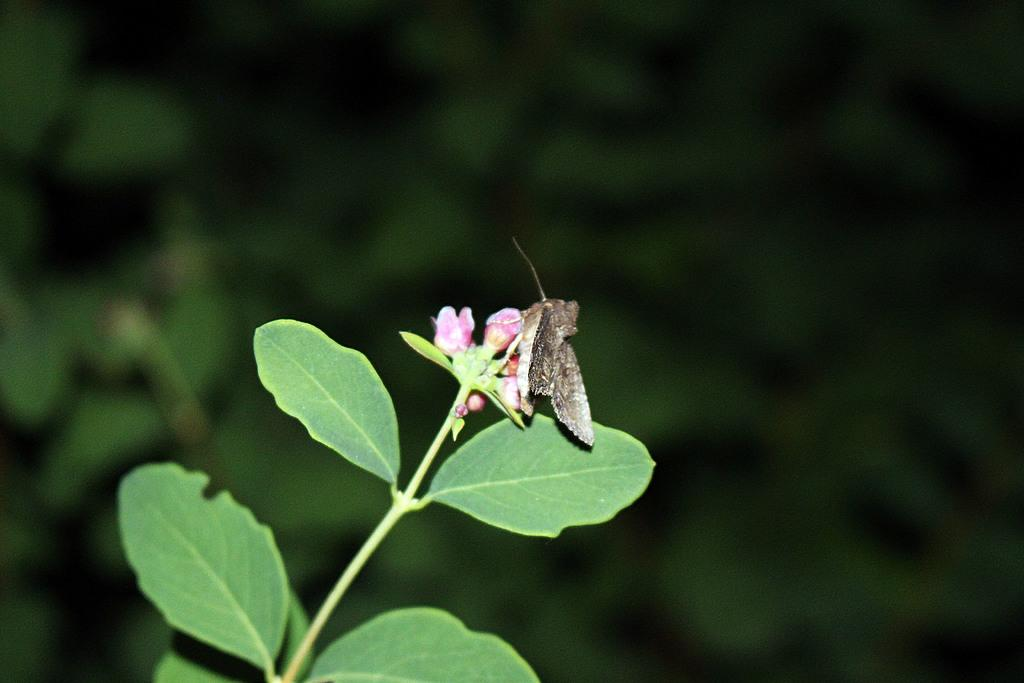What is the main subject of the image? There is a moth in the center of the image. Where is the moth located in the image? The moth is on a bud. What else can be seen in the image besides the moth? There is a plant in the image. Can you describe the background of the image? The background of the image is blurred. What type of fish can be seen swimming in the image? There is no fish present in the image; it features a moth on a bud and a plant. How many eggs are visible in the image? There are no eggs present in the image. 